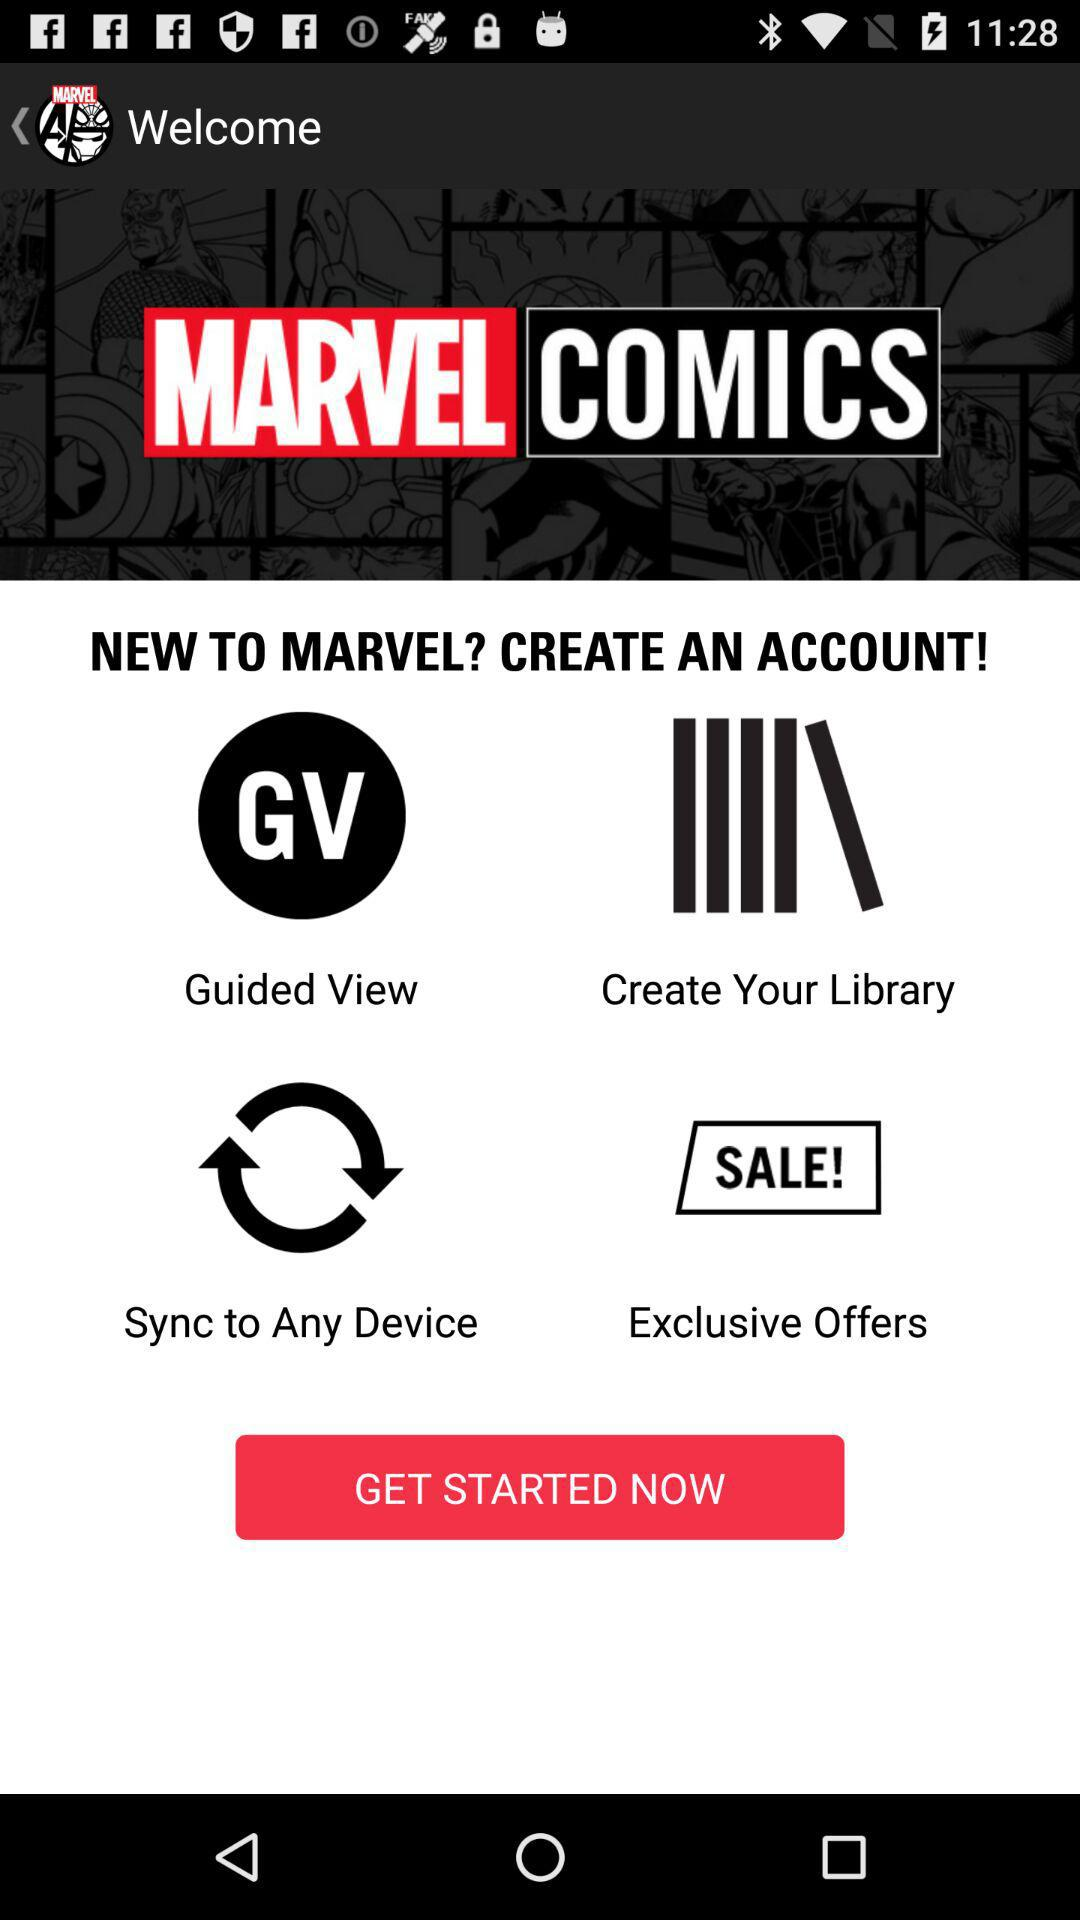What is the name of the application? The name of the application is "MARVEL COMICS". 